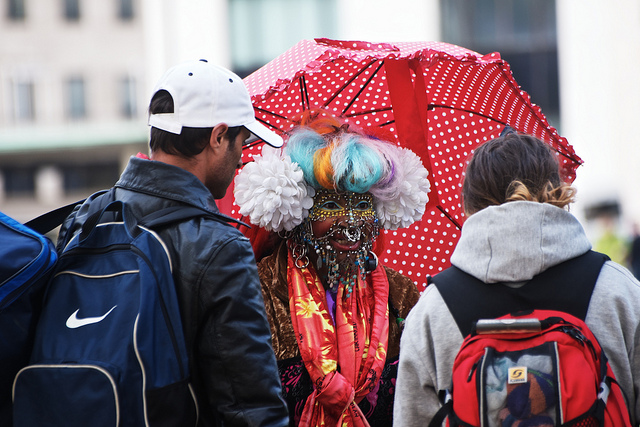<image>What color is grandma's mustache? I don't know what color grandma's mustache is. It can be brown, white, black, red, or multiple colors. What color is grandma's mustache? I don't know what color grandma's mustache is. It can be assorted, brown, white, black, multi, or red. 